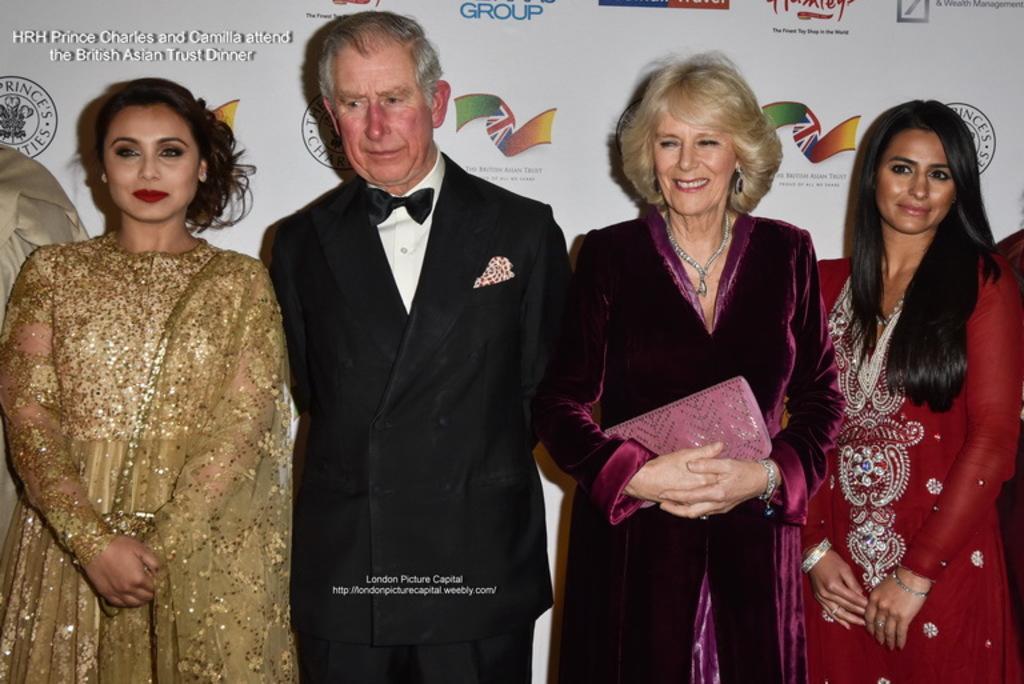Can you describe this image briefly? In this image we can see a few people standing and smiling, among them one person is holding an object, in the background we can see a poster with some images and text. 